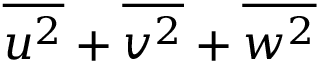<formula> <loc_0><loc_0><loc_500><loc_500>\overline { { u ^ { 2 } } } + \overline { { v ^ { 2 } } } + \overline { { w ^ { 2 } } }</formula> 